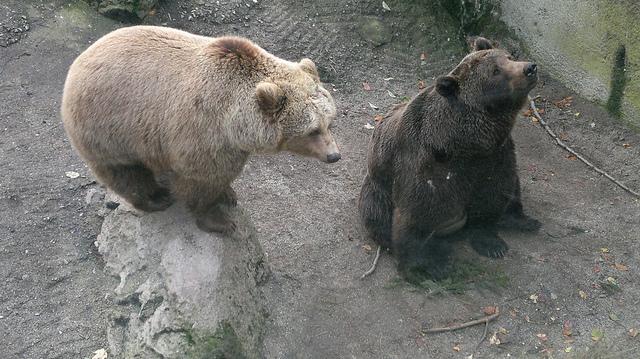Is one of the bears sitting on a rock?
Be succinct. Yes. Are the bears the same color?
Be succinct. No. How many bears are there?
Concise answer only. 2. 